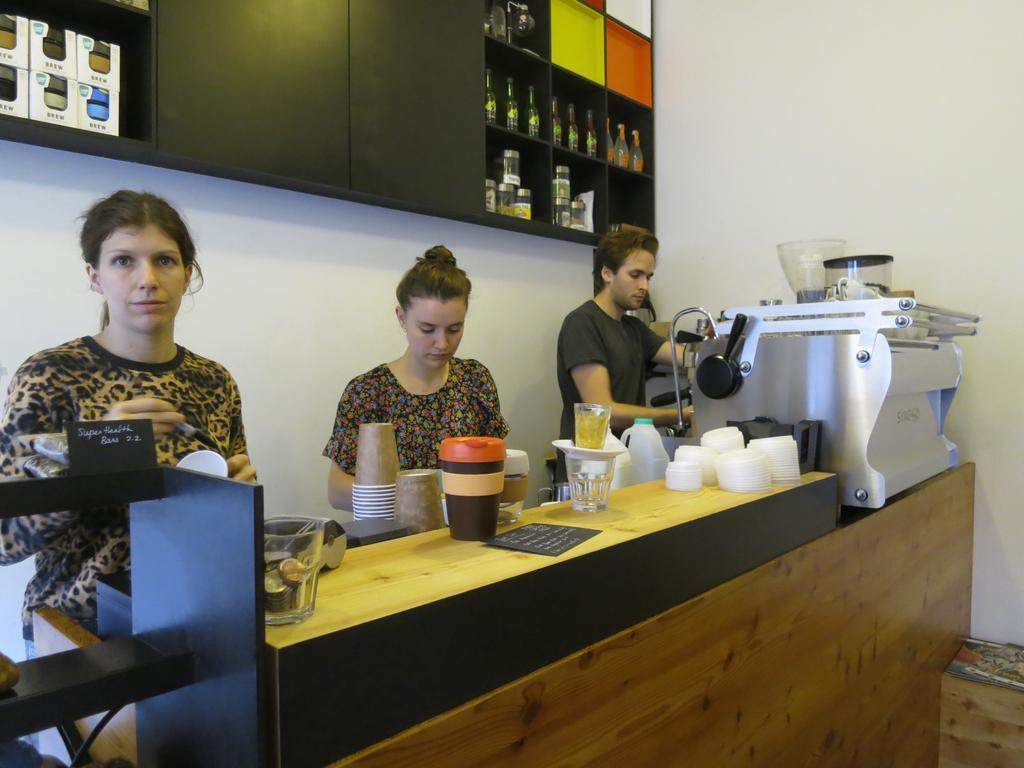Describe this image in one or two sentences. In this picture three people are standing on the other side of a table. In the background we observe a wooden shelf with containers , glass bottles. This picture is clicked inside a restaurant. 